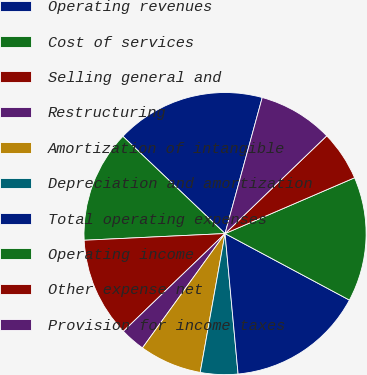Convert chart. <chart><loc_0><loc_0><loc_500><loc_500><pie_chart><fcel>Operating revenues<fcel>Cost of services<fcel>Selling general and<fcel>Restructuring<fcel>Amortization of intangible<fcel>Depreciation and amortization<fcel>Total operating expenses<fcel>Operating income<fcel>Other expense net<fcel>Provision for income taxes<nl><fcel>17.14%<fcel>12.86%<fcel>11.43%<fcel>2.86%<fcel>7.14%<fcel>4.29%<fcel>15.71%<fcel>14.29%<fcel>5.71%<fcel>8.57%<nl></chart> 